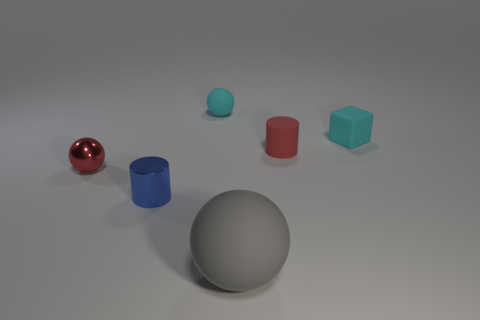Subtract all big rubber balls. How many balls are left? 2 Add 1 tiny blue cylinders. How many objects exist? 7 Subtract all cubes. How many objects are left? 5 Subtract 1 spheres. How many spheres are left? 2 Subtract all cyan balls. How many balls are left? 2 Subtract all small cyan cylinders. Subtract all rubber cylinders. How many objects are left? 5 Add 1 cyan matte balls. How many cyan matte balls are left? 2 Add 6 gray metal spheres. How many gray metal spheres exist? 6 Subtract 0 green cylinders. How many objects are left? 6 Subtract all brown balls. Subtract all cyan cubes. How many balls are left? 3 